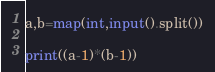Convert code to text. <code><loc_0><loc_0><loc_500><loc_500><_Python_>a,b=map(int,input().split())

print((a-1)*(b-1))
</code> 